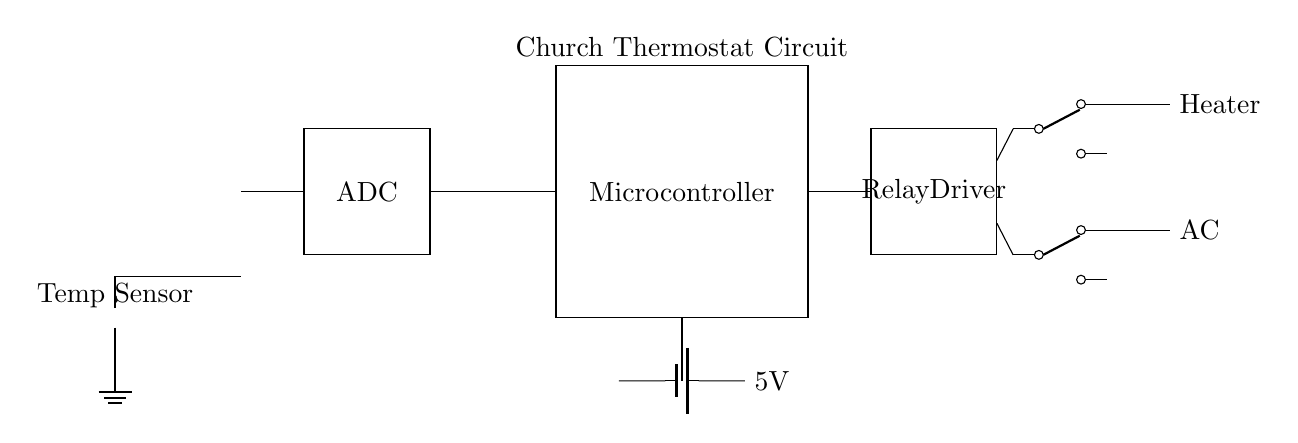What type of temperature sensor is used? The circuit uses a thermistor, which is indicated by the symbol in the diagram. A thermistor is a type of temperature sensor that changes resistance with temperature variations.
Answer: Thermistor What is the voltage of the power supply? The diagram shows a battery with a labeled voltage of 5 volts, which provides power to the circuit components.
Answer: 5 volts How many relays are present in the circuit? There are two relays shown in the circuit, one for heating and one for cooling, indicated by the symbols present on the diagram.
Answer: Two What components connect to the microcontroller? The ADC connects to the microcontroller as an input, and the relay driver connects to the microcontroller as an output. This indicates the flow of control signals from the microcontroller to manage the relays.
Answer: ADC and Relay Driver What is the function of the relay driver? The relay driver in the circuit is responsible for controlling the operation of the heating and cooling relays based on the commands received from the microcontroller. It acts as an interface between the microcontroller and the high-power devices.
Answer: Control relays How does the circuit regulate heating and cooling? The microcontroller reads the temperature from the thermistor via the ADC, processes the data, and then sends commands to either activate the heating relay or the cooling relay. This feedback loop allows regulation of the temperature based on the set parameters.
Answer: Feedback loop What actions are taken when the output relays are activated? When the heating relay is activated, the circuit connects to the heater, allowing it to turn on and warm the church. Conversely, activating the cooling relay connects to the AC, turning it on and cooling the space.
Answer: Turns on heater or AC 